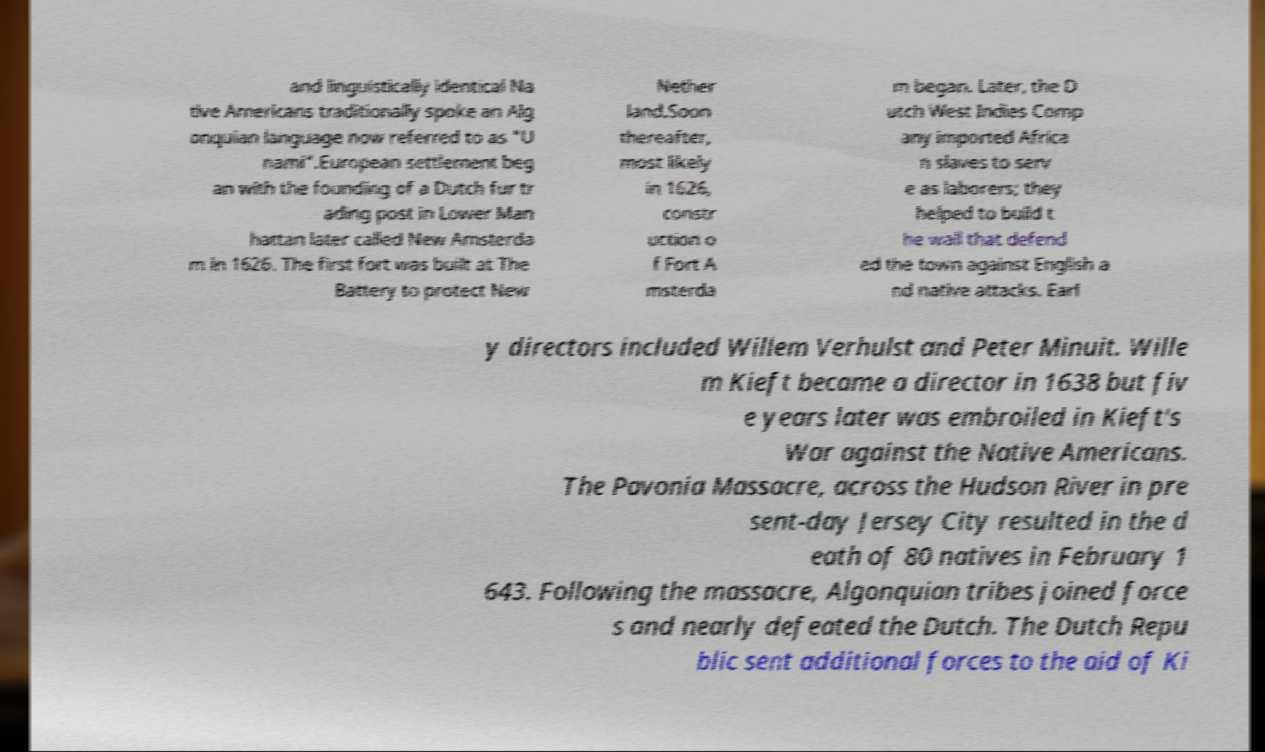There's text embedded in this image that I need extracted. Can you transcribe it verbatim? and linguistically identical Na tive Americans traditionally spoke an Alg onquian language now referred to as "U nami".European settlement beg an with the founding of a Dutch fur tr ading post in Lower Man hattan later called New Amsterda m in 1626. The first fort was built at The Battery to protect New Nether land.Soon thereafter, most likely in 1626, constr uction o f Fort A msterda m began. Later, the D utch West Indies Comp any imported Africa n slaves to serv e as laborers; they helped to build t he wall that defend ed the town against English a nd native attacks. Earl y directors included Willem Verhulst and Peter Minuit. Wille m Kieft became a director in 1638 but fiv e years later was embroiled in Kieft's War against the Native Americans. The Pavonia Massacre, across the Hudson River in pre sent-day Jersey City resulted in the d eath of 80 natives in February 1 643. Following the massacre, Algonquian tribes joined force s and nearly defeated the Dutch. The Dutch Repu blic sent additional forces to the aid of Ki 